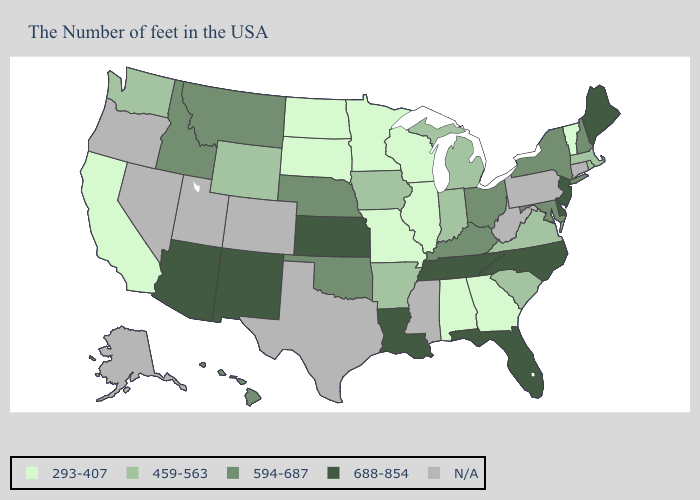What is the value of California?
Short answer required. 293-407. Name the states that have a value in the range 594-687?
Concise answer only. New Hampshire, New York, Maryland, Ohio, Kentucky, Nebraska, Oklahoma, Montana, Idaho, Hawaii. Does Nebraska have the lowest value in the MidWest?
Keep it brief. No. What is the value of North Dakota?
Be succinct. 293-407. Does the map have missing data?
Be succinct. Yes. Name the states that have a value in the range N/A?
Short answer required. Connecticut, Pennsylvania, West Virginia, Mississippi, Texas, Colorado, Utah, Nevada, Oregon, Alaska. What is the highest value in states that border Utah?
Answer briefly. 688-854. How many symbols are there in the legend?
Answer briefly. 5. Which states hav the highest value in the South?
Short answer required. Delaware, North Carolina, Florida, Tennessee, Louisiana. What is the value of North Dakota?
Write a very short answer. 293-407. What is the value of Montana?
Concise answer only. 594-687. Which states have the highest value in the USA?
Keep it brief. Maine, New Jersey, Delaware, North Carolina, Florida, Tennessee, Louisiana, Kansas, New Mexico, Arizona. Which states have the lowest value in the USA?
Be succinct. Vermont, Georgia, Alabama, Wisconsin, Illinois, Missouri, Minnesota, South Dakota, North Dakota, California. Which states hav the highest value in the MidWest?
Give a very brief answer. Kansas. 